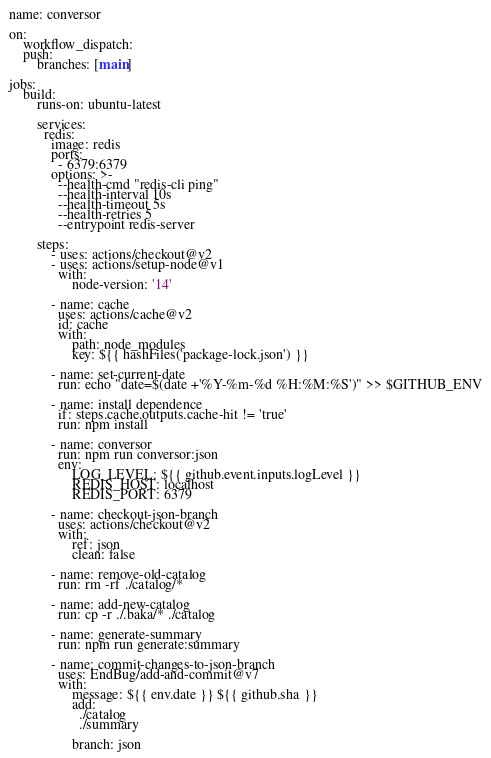Convert code to text. <code><loc_0><loc_0><loc_500><loc_500><_YAML_>name: conversor

on:
    workflow_dispatch:
    push:
        branches: [main]

jobs:
    build:
        runs-on: ubuntu-latest
        
        services:
          redis:
            image: redis
            ports:
              - 6379:6379
            options: >-
              --health-cmd "redis-cli ping"
              --health-interval 10s
              --health-timeout 5s
              --health-retries 5
              --entrypoint redis-server

        steps:
            - uses: actions/checkout@v2
            - uses: actions/setup-node@v1
              with:
                  node-version: '14'

            - name: cache
              uses: actions/cache@v2
              id: cache
              with:
                  path: node_modules
                  key: ${{ hashFiles('package-lock.json') }}

            - name: set-current-date
              run: echo "date=$(date +'%Y-%m-%d %H:%M:%S')" >> $GITHUB_ENV

            - name: install dependence
              if: steps.cache.outputs.cache-hit != 'true'
              run: npm install

            - name: conversor
              run: npm run conversor:json
              env:
                  LOG_LEVEL: ${{ github.event.inputs.logLevel }}
                  REDIS_HOST: localhost
                  REDIS_PORT: 6379

            - name: checkout-json-branch
              uses: actions/checkout@v2
              with:
                  ref: json
                  clean: false

            - name: remove-old-catalog
              run: rm -rf ./catalog/*

            - name: add-new-catalog
              run: cp -r ./.baka/* ./catalog

            - name: generate-summary
              run: npm run generate:summary

            - name: commit-changes-to-json-branch
              uses: EndBug/add-and-commit@v7
              with:
                  message: ${{ env.date }} ${{ github.sha }}
                  add:
                    ./catalog
                    ./summary

                  branch: json
</code> 